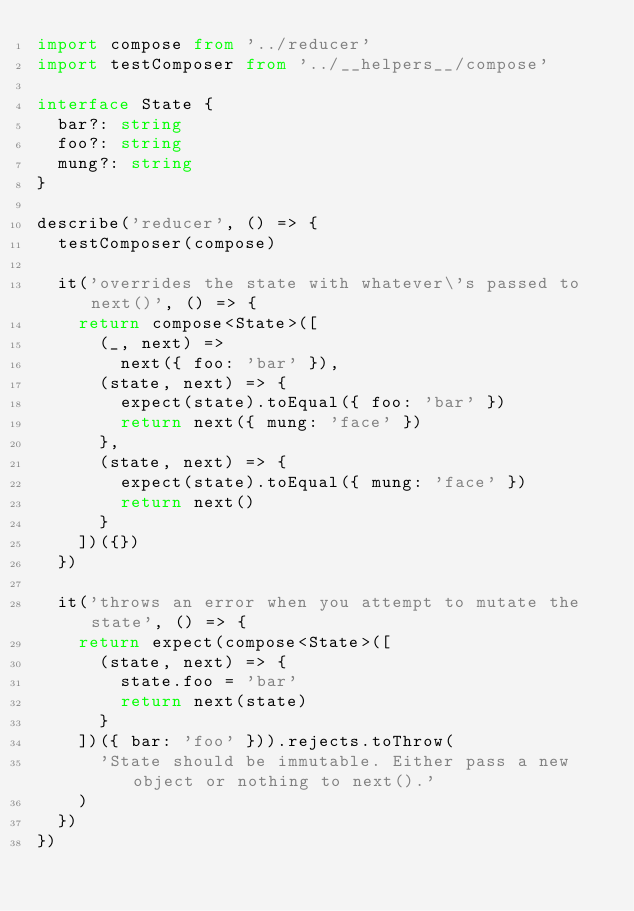<code> <loc_0><loc_0><loc_500><loc_500><_TypeScript_>import compose from '../reducer'
import testComposer from '../__helpers__/compose'

interface State {
  bar?: string
  foo?: string
  mung?: string
}

describe('reducer', () => {
  testComposer(compose)

  it('overrides the state with whatever\'s passed to next()', () => {
    return compose<State>([
      (_, next) =>
        next({ foo: 'bar' }),
      (state, next) => {
        expect(state).toEqual({ foo: 'bar' })
        return next({ mung: 'face' })
      },
      (state, next) => {
        expect(state).toEqual({ mung: 'face' })
        return next()
      }
    ])({})
  })

  it('throws an error when you attempt to mutate the state', () => {
    return expect(compose<State>([
      (state, next) => {
        state.foo = 'bar'
        return next(state)
      }
    ])({ bar: 'foo' })).rejects.toThrow(
      'State should be immutable. Either pass a new object or nothing to next().'
    )
  })
})
</code> 